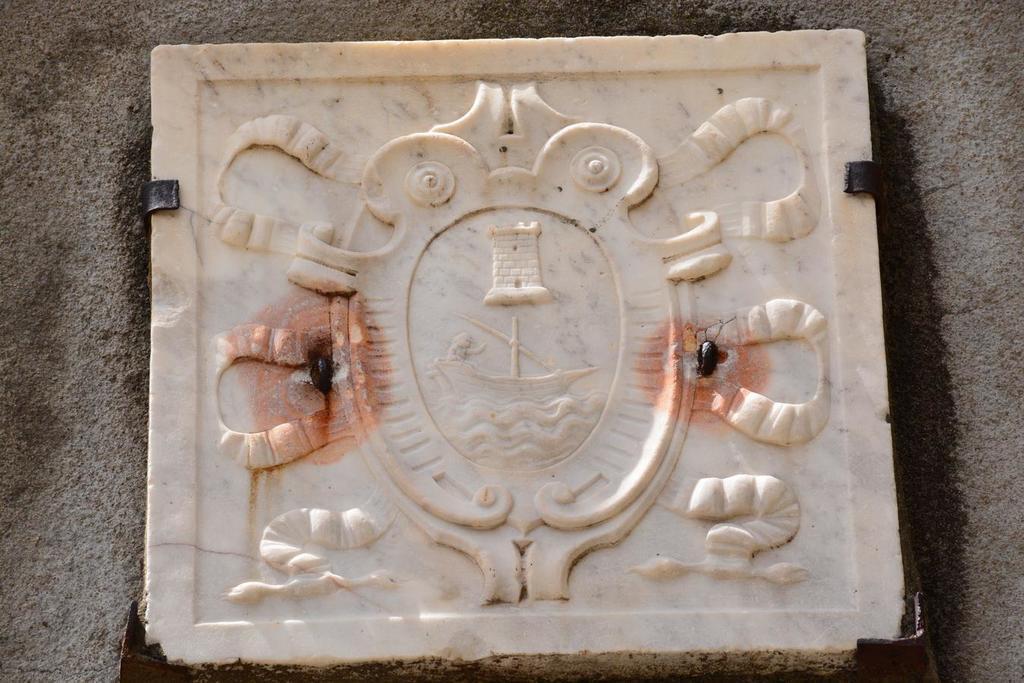Could you give a brief overview of what you see in this image? In this picture, we can see a carved marble stone on the surface. 